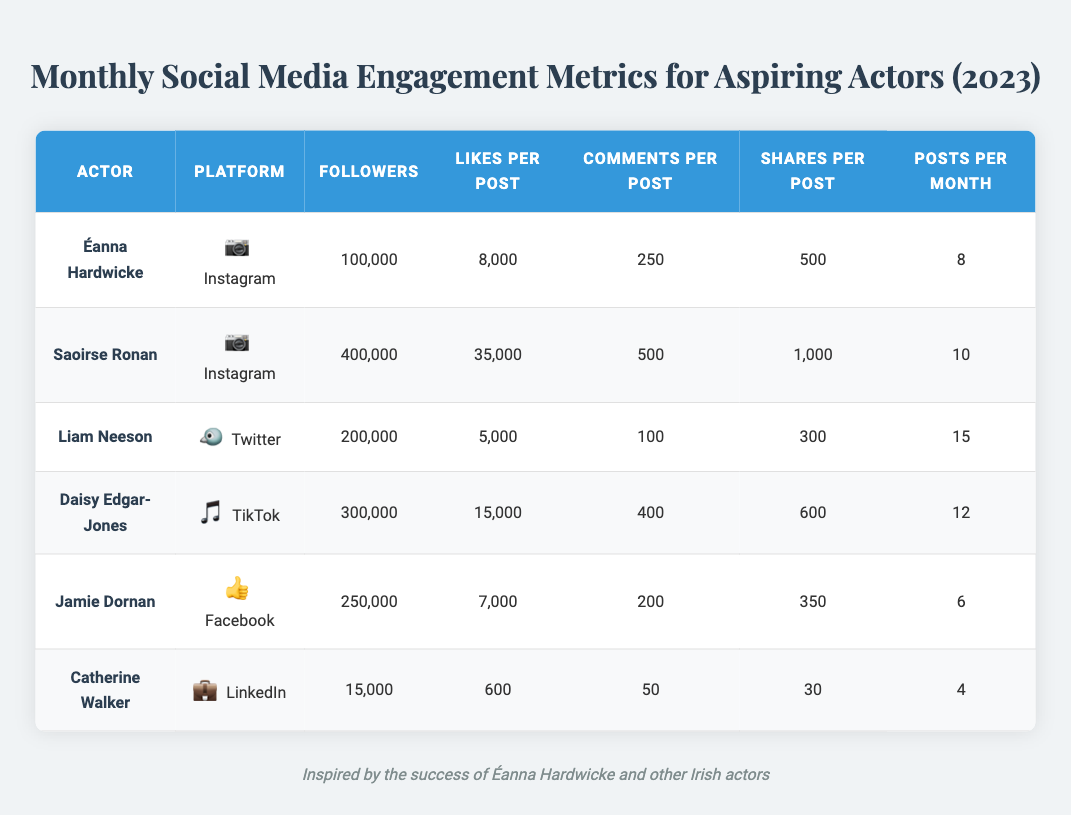What is the total number of Instagram followers for both Éanna Hardwicke and Saoirse Ronan? Éanna Hardwicke has 100,000 Instagram followers and Saoirse Ronan has 400,000 Instagram followers. Adding these together gives 100,000 + 400,000 = 500,000.
Answer: 500,000 What platform does Liam Neeson use? The table lists Liam Neeson under the Twitter platform.
Answer: Twitter How many posts does Daisy Edgar-Jones make per month on TikTok? The table shows that Daisy Edgar-Jones posts 12 videos each month on TikTok.
Answer: 12 Does Catherine Walker have more than 20,000 followers? Catherine Walker has 15,000 followers, which is less than 20,000.
Answer: No What are the total likes received per month by Jamie Dornan on Facebook? Jamie Dornan has 7,000 likes per post and posts 6 times a month. To find the total monthly likes, multiply 7,000 by 6, which equals 42,000.
Answer: 42,000 Who has the highest average engagement on Instagram based on likes and comments per post? For Éanna Hardwicke, the engagement is 8,000 likes and 250 comments per post, giving a total of 8,250. For Saoirse Ronan, it is 35,000 likes and 500 comments, totaling 35,500. Saoirse Ronan has the highest engagement.
Answer: Saoirse Ronan What is the median number of shares per post across all actors listed? To find the median number of shares per post, we look at the shares: Éanna Hardwicke (500), Saoirse Ronan (1,000), Liam Neeson (300), Daisy Edgar-Jones (600), Jamie Dornan (350), Catherine Walker (30). Ordered values are 30, 300, 350, 500, 600, 1,000. The median of these six numbers (the average of 350 and 500) is (350 + 500) / 2 = 425.
Answer: 425 Which actor has the highest number of likes per post overall? The likes per post figures are as follows: Éanna Hardwicke (8,000), Saoirse Ronan (35,000), Liam Neeson (5,000), Daisy Edgar-Jones (15,000), Jamie Dornan (7,000), and Catherine Walker (600). Saoirse Ronan has the highest at 35,000 likes per post.
Answer: Saoirse Ronan How many shares does Daisy Edgar-Jones receive in total each month? Daisy Edgar-Jones has 600 shares per video and posts 12 videos per month. Therefore, the total shares are 600 x 12 = 7,200.
Answer: 7,200 